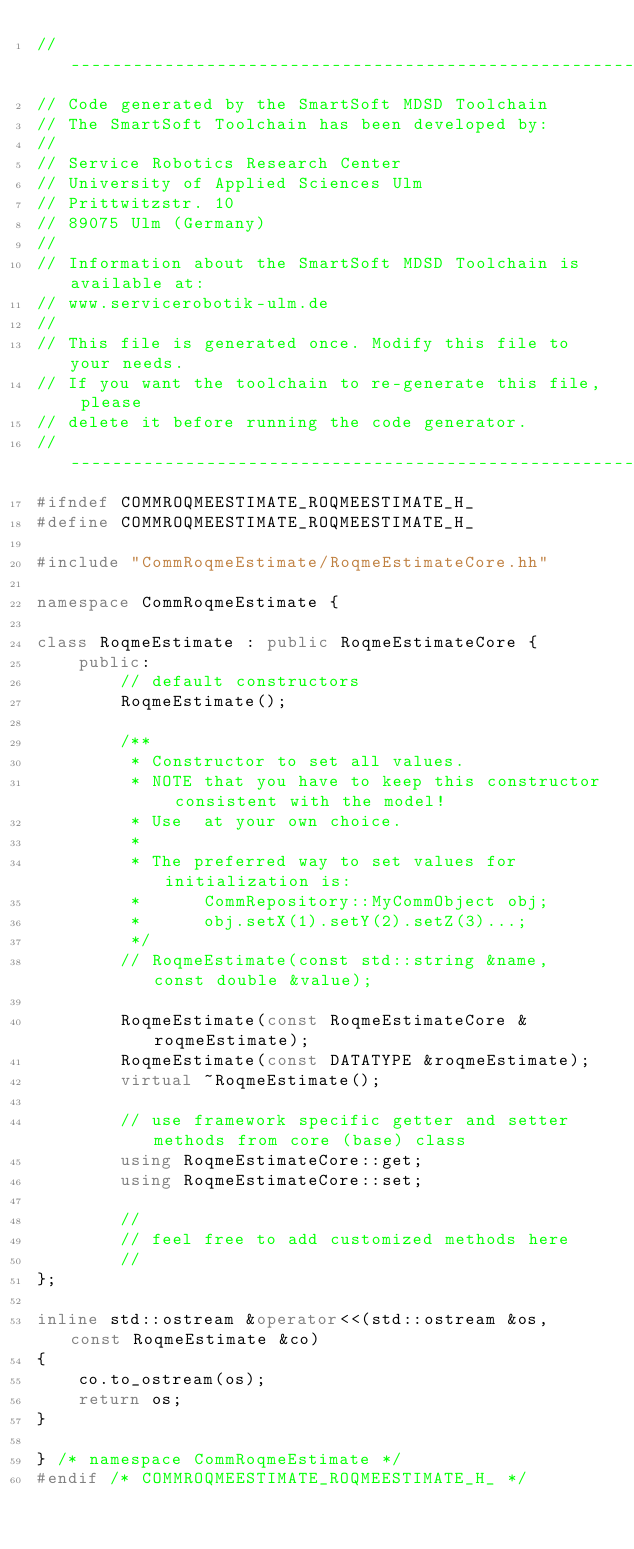Convert code to text. <code><loc_0><loc_0><loc_500><loc_500><_C++_>//--------------------------------------------------------------------------
// Code generated by the SmartSoft MDSD Toolchain
// The SmartSoft Toolchain has been developed by:
//  
// Service Robotics Research Center
// University of Applied Sciences Ulm
// Prittwitzstr. 10
// 89075 Ulm (Germany)
//
// Information about the SmartSoft MDSD Toolchain is available at:
// www.servicerobotik-ulm.de
//
// This file is generated once. Modify this file to your needs. 
// If you want the toolchain to re-generate this file, please 
// delete it before running the code generator.
//--------------------------------------------------------------------------
#ifndef COMMROQMEESTIMATE_ROQMEESTIMATE_H_
#define COMMROQMEESTIMATE_ROQMEESTIMATE_H_

#include "CommRoqmeEstimate/RoqmeEstimateCore.hh"

namespace CommRoqmeEstimate {
		
class RoqmeEstimate : public RoqmeEstimateCore {
	public:
		// default constructors
		RoqmeEstimate();
		
		/**
		 * Constructor to set all values.
		 * NOTE that you have to keep this constructor consistent with the model!
		 * Use  at your own choice.
		 *
		 * The preferred way to set values for initialization is:
		 *      CommRepository::MyCommObject obj;
		 *      obj.setX(1).setY(2).setZ(3)...;
		 */
		// RoqmeEstimate(const std::string &name, const double &value);
		
		RoqmeEstimate(const RoqmeEstimateCore &roqmeEstimate);
		RoqmeEstimate(const DATATYPE &roqmeEstimate);
		virtual ~RoqmeEstimate();
		
		// use framework specific getter and setter methods from core (base) class
		using RoqmeEstimateCore::get;
		using RoqmeEstimateCore::set;
		
		//
		// feel free to add customized methods here
		//
};

inline std::ostream &operator<<(std::ostream &os, const RoqmeEstimate &co)
{
	co.to_ostream(os);
	return os;
}
	
} /* namespace CommRoqmeEstimate */
#endif /* COMMROQMEESTIMATE_ROQMEESTIMATE_H_ */
</code> 